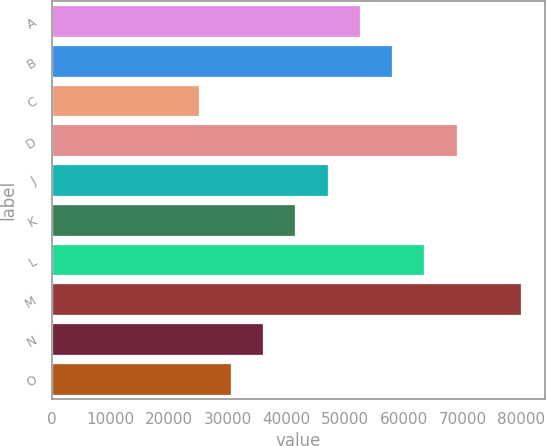Convert chart. <chart><loc_0><loc_0><loc_500><loc_500><bar_chart><fcel>A<fcel>B<fcel>C<fcel>D<fcel>J<fcel>K<fcel>L<fcel>M<fcel>N<fcel>O<nl><fcel>52500<fcel>58000<fcel>25000<fcel>69000<fcel>47000<fcel>41500<fcel>63500<fcel>80000<fcel>36000<fcel>30500<nl></chart> 